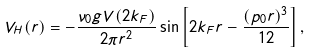Convert formula to latex. <formula><loc_0><loc_0><loc_500><loc_500>V _ { H } ( r ) = - \frac { \nu _ { 0 } g V ( 2 k _ { F } ) } { 2 \pi r ^ { 2 } } \sin \left [ 2 k _ { F } r - \frac { ( p _ { 0 } r ) ^ { 3 } } { 1 2 } \right ] ,</formula> 